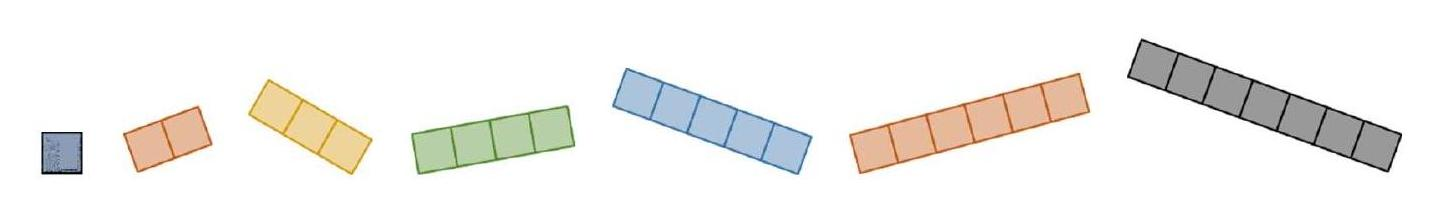Gaspar has these seven different pieces, formed by equal little squares. He uses all these pieces to assemble rectangles with different perimeters, that is, with different shapes. How many different perimeters can he find? Given the image depicting seven different pentominoes, Gaspar can find exactly three distinct perimeters when using these pieces to construct rectangles. The different possible perimeters arise due to the varied ways in which the pieces can be arranged to form rectangles, either by aligning them in more elongated formations or more compact shapes. This variability in arrangement allows for distinctive perimeter lengths. 